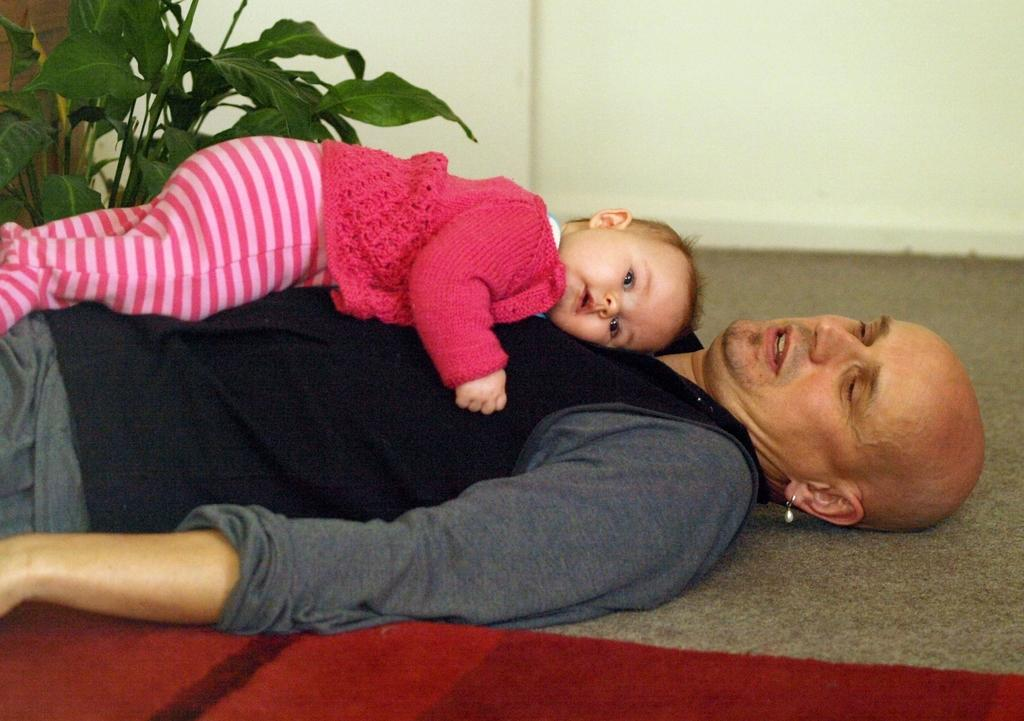Who is the main subject in the image? There is a man in the image. What is the man doing in the image? The man is holding a baby. What is on the floor in the image? There is a carpet on the floor in the image. What type of vegetation is present in the image? There is a plant in the image. What can be seen in the background of the image? There is a wall visible in the background of the image. What type of shop can be seen in the background of the image? There is no shop visible in the image; only a wall is present in the background. How does the man balance the baby while holding it in the image? The image does not provide information on how the man is holding or balancing the baby, only that he is holding it. 